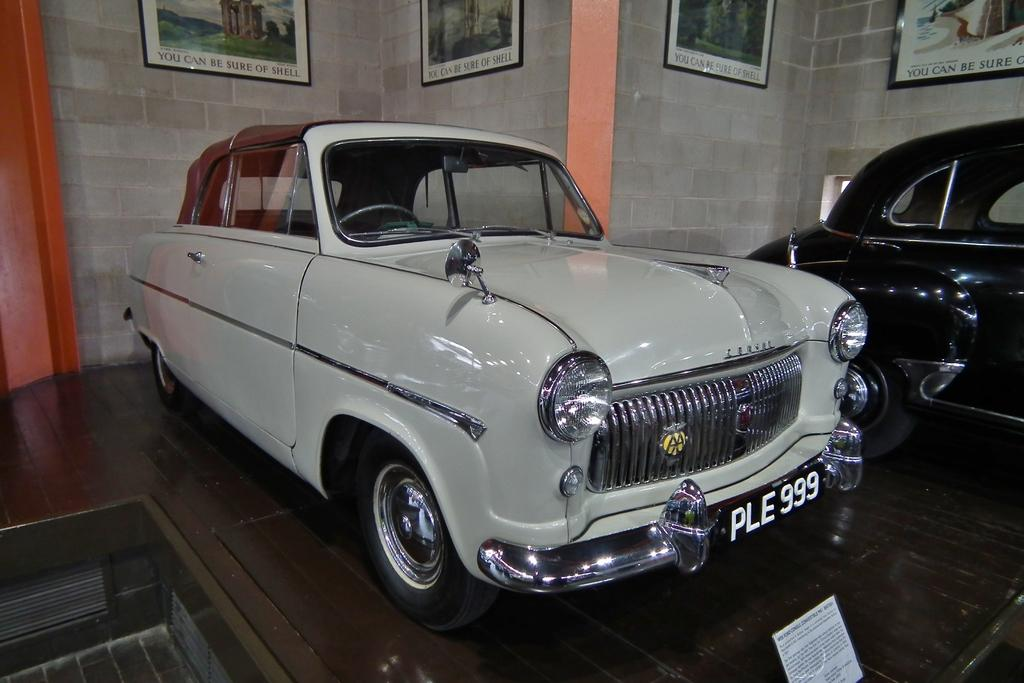How many cars are present in the image? There are two cars in the image. Where are the cars located? The cars are on the floor. Is there any identification on one of the cars? Yes, there is a number plate on one of the cars. What else can be seen on the floor besides the cars? A paper is visible on the floor. What is present on the wall in the image? There are frames on the wall. Can you describe the cow that is standing under the shade in the image? There is no cow or shade present in the image; it only features two cars, a paper on the floor, and frames on the wall. 